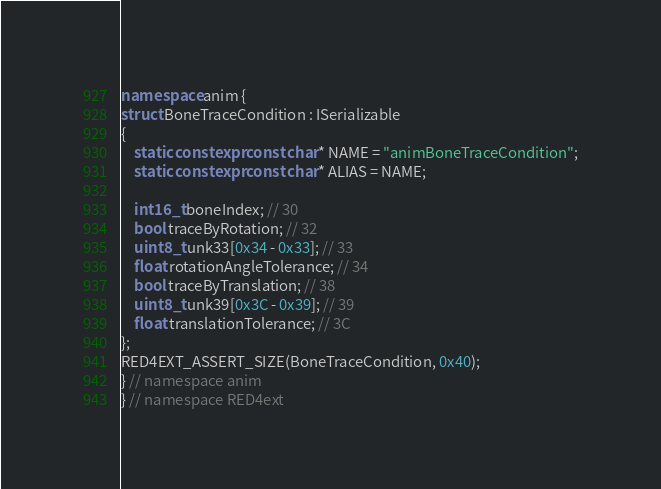Convert code to text. <code><loc_0><loc_0><loc_500><loc_500><_C++_>namespace anim { 
struct BoneTraceCondition : ISerializable
{
    static constexpr const char* NAME = "animBoneTraceCondition";
    static constexpr const char* ALIAS = NAME;

    int16_t boneIndex; // 30
    bool traceByRotation; // 32
    uint8_t unk33[0x34 - 0x33]; // 33
    float rotationAngleTolerance; // 34
    bool traceByTranslation; // 38
    uint8_t unk39[0x3C - 0x39]; // 39
    float translationTolerance; // 3C
};
RED4EXT_ASSERT_SIZE(BoneTraceCondition, 0x40);
} // namespace anim
} // namespace RED4ext
</code> 